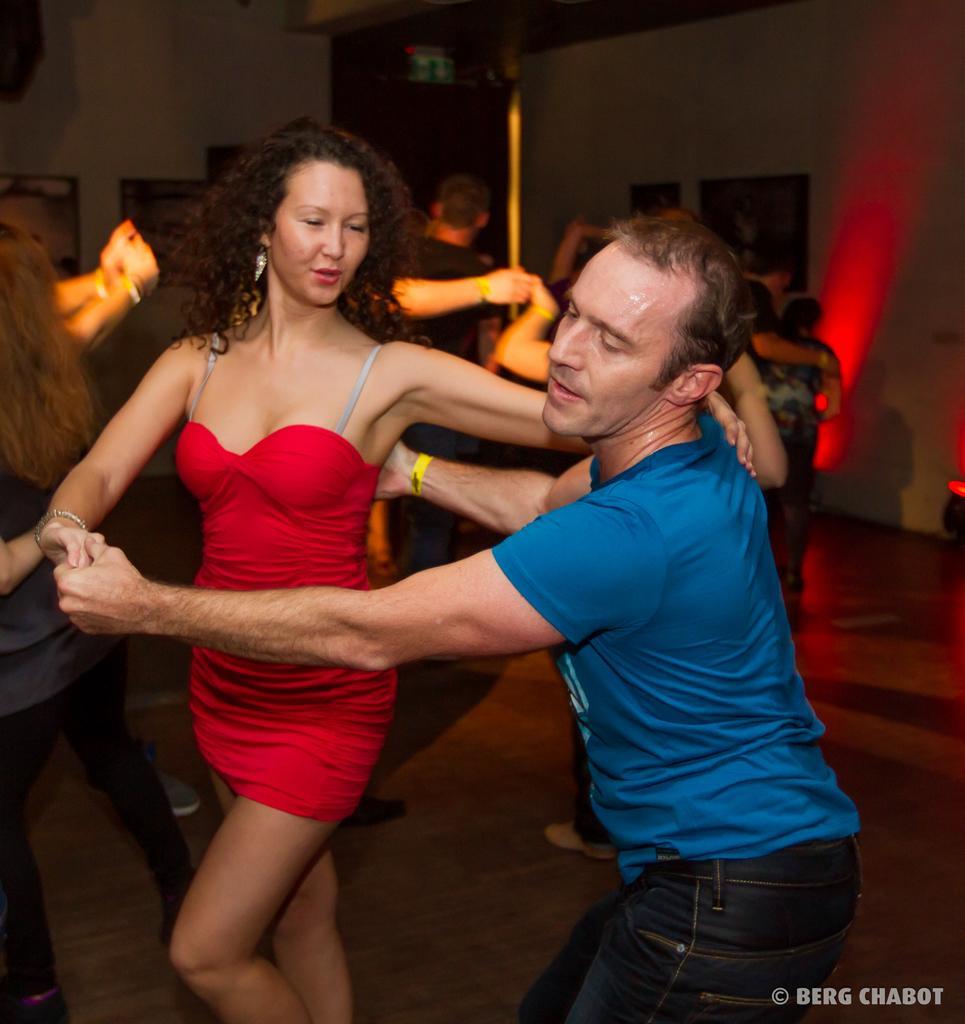Please provide a concise description of this image. In the center of the image there are people dancing. In the background of the image there is wall. 